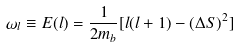Convert formula to latex. <formula><loc_0><loc_0><loc_500><loc_500>\omega _ { l } \equiv E ( l ) = \frac { 1 } { 2 m _ { b } } [ l ( l + 1 ) - ( \Delta S ) ^ { 2 } ]</formula> 